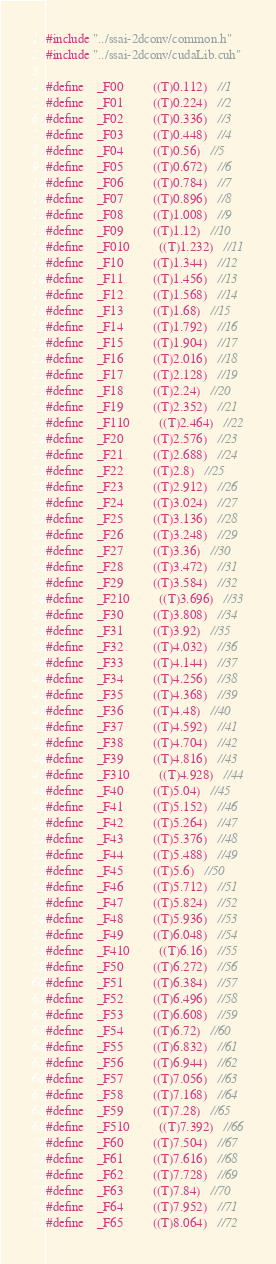Convert code to text. <code><loc_0><loc_0><loc_500><loc_500><_Cuda_>#include "../ssai-2dconv/common.h"
#include "../ssai-2dconv/cudaLib.cuh"

#define    _F00         ((T)0.112)   //1
#define    _F01         ((T)0.224)   //2
#define    _F02         ((T)0.336)   //3
#define    _F03         ((T)0.448)   //4
#define    _F04         ((T)0.56)   //5
#define    _F05         ((T)0.672)   //6
#define    _F06         ((T)0.784)   //7
#define    _F07         ((T)0.896)   //8
#define    _F08         ((T)1.008)   //9
#define    _F09         ((T)1.12)   //10
#define    _F010         ((T)1.232)   //11
#define    _F10         ((T)1.344)   //12
#define    _F11         ((T)1.456)   //13
#define    _F12         ((T)1.568)   //14
#define    _F13         ((T)1.68)   //15
#define    _F14         ((T)1.792)   //16
#define    _F15         ((T)1.904)   //17
#define    _F16         ((T)2.016)   //18
#define    _F17         ((T)2.128)   //19
#define    _F18         ((T)2.24)   //20
#define    _F19         ((T)2.352)   //21
#define    _F110         ((T)2.464)   //22
#define    _F20         ((T)2.576)   //23
#define    _F21         ((T)2.688)   //24
#define    _F22         ((T)2.8)   //25
#define    _F23         ((T)2.912)   //26
#define    _F24         ((T)3.024)   //27
#define    _F25         ((T)3.136)   //28
#define    _F26         ((T)3.248)   //29
#define    _F27         ((T)3.36)   //30
#define    _F28         ((T)3.472)   //31
#define    _F29         ((T)3.584)   //32
#define    _F210         ((T)3.696)   //33
#define    _F30         ((T)3.808)   //34
#define    _F31         ((T)3.92)   //35
#define    _F32         ((T)4.032)   //36
#define    _F33         ((T)4.144)   //37
#define    _F34         ((T)4.256)   //38
#define    _F35         ((T)4.368)   //39
#define    _F36         ((T)4.48)   //40
#define    _F37         ((T)4.592)   //41
#define    _F38         ((T)4.704)   //42
#define    _F39         ((T)4.816)   //43
#define    _F310         ((T)4.928)   //44
#define    _F40         ((T)5.04)   //45
#define    _F41         ((T)5.152)   //46
#define    _F42         ((T)5.264)   //47
#define    _F43         ((T)5.376)   //48
#define    _F44         ((T)5.488)   //49
#define    _F45         ((T)5.6)   //50
#define    _F46         ((T)5.712)   //51
#define    _F47         ((T)5.824)   //52
#define    _F48         ((T)5.936)   //53
#define    _F49         ((T)6.048)   //54
#define    _F410         ((T)6.16)   //55
#define    _F50         ((T)6.272)   //56
#define    _F51         ((T)6.384)   //57
#define    _F52         ((T)6.496)   //58
#define    _F53         ((T)6.608)   //59
#define    _F54         ((T)6.72)   //60
#define    _F55         ((T)6.832)   //61
#define    _F56         ((T)6.944)   //62
#define    _F57         ((T)7.056)   //63
#define    _F58         ((T)7.168)   //64
#define    _F59         ((T)7.28)   //65
#define    _F510         ((T)7.392)   //66
#define    _F60         ((T)7.504)   //67
#define    _F61         ((T)7.616)   //68
#define    _F62         ((T)7.728)   //69
#define    _F63         ((T)7.84)   //70
#define    _F64         ((T)7.952)   //71
#define    _F65         ((T)8.064)   //72</code> 